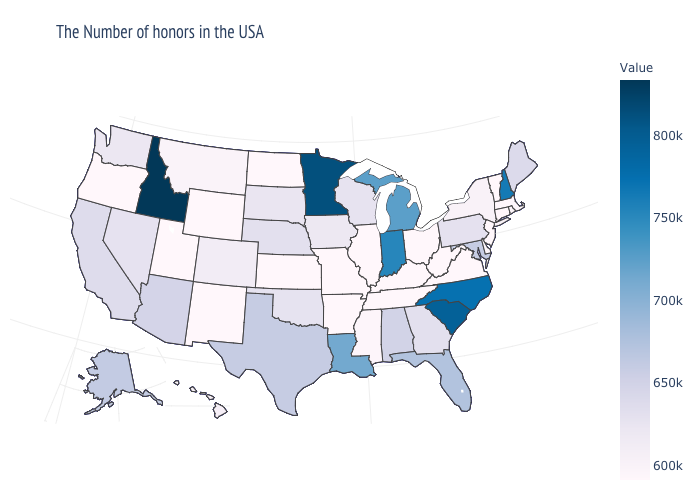Which states have the lowest value in the MidWest?
Be succinct. Ohio, Illinois, Missouri, Kansas, North Dakota. Is the legend a continuous bar?
Give a very brief answer. Yes. Does Georgia have a higher value than Vermont?
Answer briefly. Yes. Among the states that border Tennessee , which have the highest value?
Answer briefly. North Carolina. Which states have the lowest value in the Northeast?
Keep it brief. Vermont, Connecticut, New Jersey. Does Wyoming have a higher value than Georgia?
Answer briefly. No. 